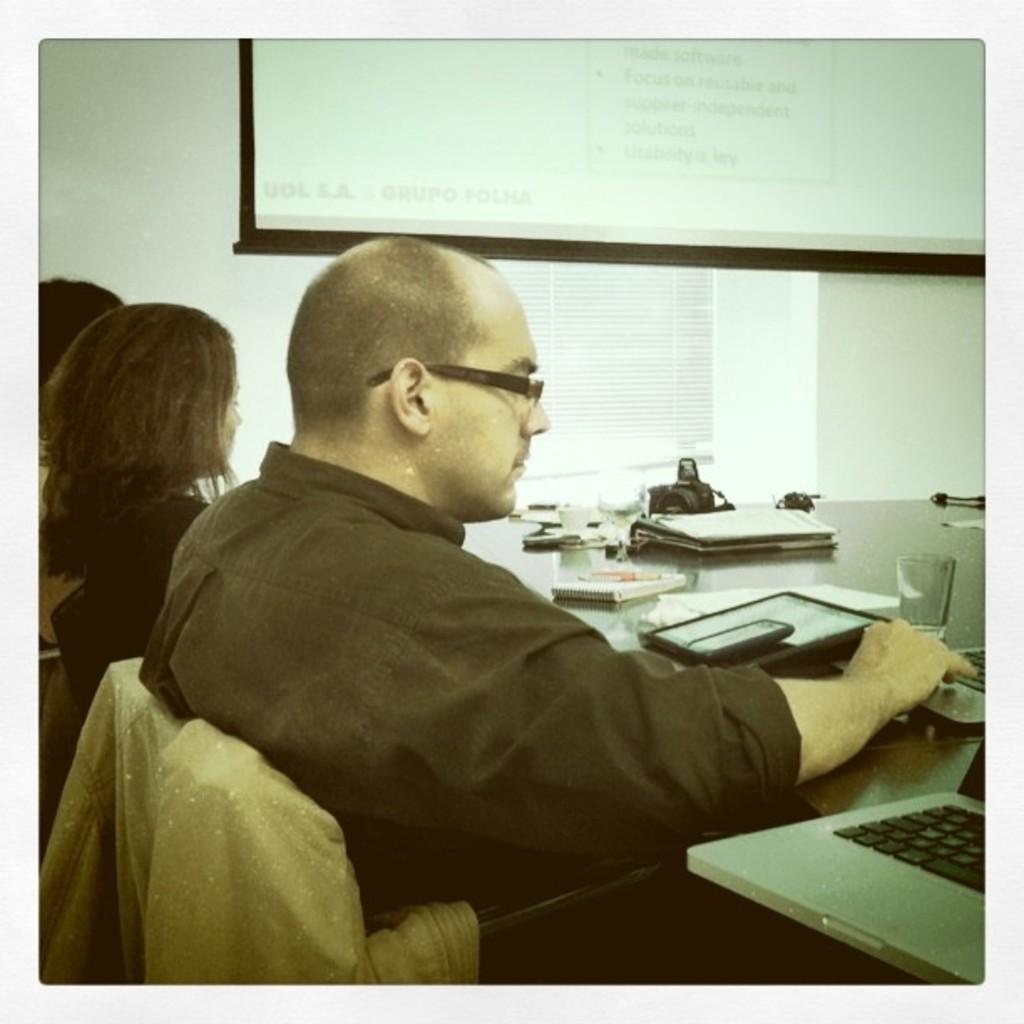In one or two sentences, can you explain what this image depicts? In this image I can see few persons are sitting on chairs and in the front I can see one of them is wearing specs. On the right side of this image I can see a table and on it I can see few laptops, few electronic devices, a glass, a notebook, a pen, a camera and few other stuffs. On the top side of this image I can see a projector screen and on it I can see something is written. 